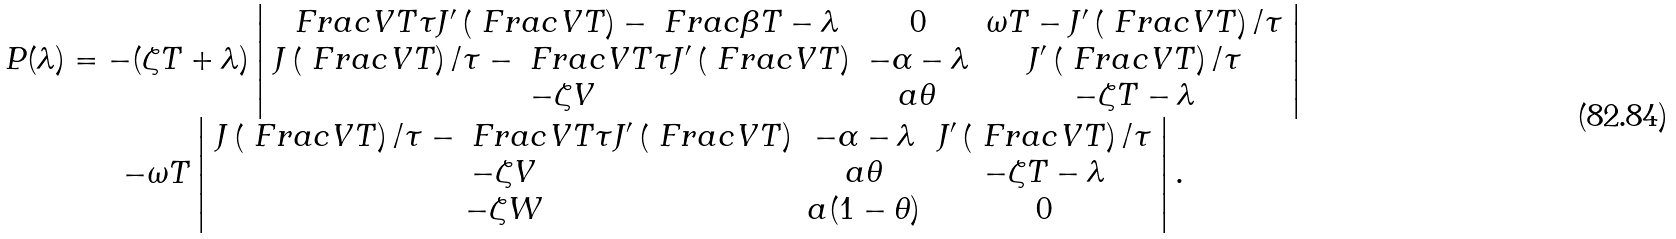Convert formula to latex. <formula><loc_0><loc_0><loc_500><loc_500>\begin{array} { c } P ( \lambda ) = - ( \zeta T + \lambda ) \left | \begin{array} { c c c } \ F r a c { V } { T \tau } J ^ { \prime } \left ( \ F r a c { V } { T } \right ) - \ F r a c { \beta } { T } - \lambda & 0 & \omega T - J ^ { \prime } \left ( \ F r a c { V } { T } \right ) / \tau \\ J \left ( \ F r a c { V } { T } \right ) / \tau - \ F r a c { V } { T \tau } J ^ { \prime } \left ( \ F r a c { V } { T } \right ) & - \alpha - \lambda & J ^ { \prime } \left ( \ F r a c { V } { T } \right ) / \tau \\ - \zeta V & a \theta & - \zeta T - \lambda \end{array} \right | \\ - \omega T \left | \begin{array} { c c c } J \left ( \ F r a c { V } { T } \right ) / \tau - \ F r a c { V } { T \tau } J ^ { \prime } \left ( \ F r a c { V } { T } \right ) & - \alpha - \lambda & J ^ { \prime } \left ( \ F r a c { V } { T } \right ) / \tau \\ - \zeta V & a \theta & - \zeta T - \lambda \\ - \zeta W & a ( 1 - \theta ) & 0 \end{array} \right | . \end{array}</formula> 